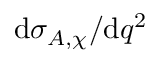Convert formula to latex. <formula><loc_0><loc_0><loc_500><loc_500>d \sigma _ { A , \chi } / d q ^ { 2 }</formula> 